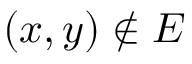Convert formula to latex. <formula><loc_0><loc_0><loc_500><loc_500>( x , y ) \notin E</formula> 